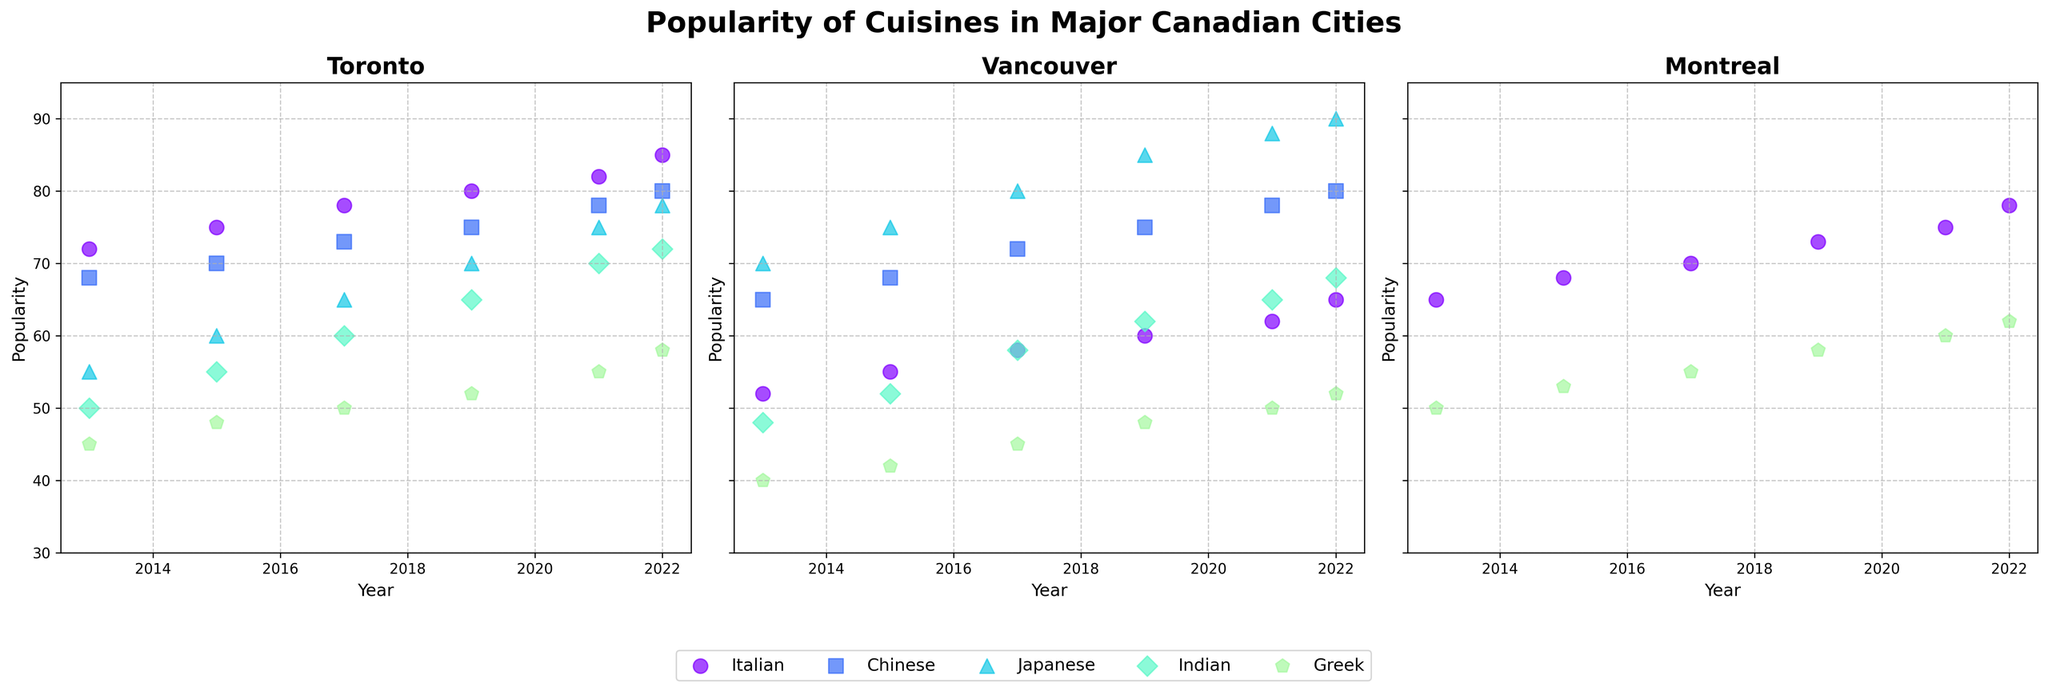Which city has the highest popularity for Japanese cuisine in 2022? Look at Japanese cuisine data points for 2022 in each city's subplot. Vancouver has the highest popularity.
Answer: Vancouver Between 2013 and 2022, which city's Italian cuisine gained the most popularity? Calculate the difference in popularity from 2013 to 2022 for Italian cuisine in each city. Montreal gained 13 (65 to 78), while Toronto gained 13 (72 to 85), and Vancouver gained 13 (52 to 65). All cities gained equally.
Answer: Tie What is the average popularity of Chinese cuisine in Montreal from 2013-2022? The years included are 2013, 2015, 2017, 2019, 2021, and 2022. Sum the popularity values and divide by the number of years: (N/A + N/A + N/A + N/A + N/A + N/A)/6 = N/A
Answer: N/A Which cuisine's popularity in Toronto first reached above 70 in 2015? Look at the 2015 data points in Toronto's subplot and identify the first cuisine surpassing 70. Italian cuisine was the first to reach above 70.
Answer: Italian Compare the trends of Indian cuisine popularity in Vancouver and Montreal between 2013 and 2022. Examine the scatter points for Indian cuisine in both cities, noting the fluctuations over the years. Indian cuisine in Vancouver gradually increased from 48 to 68, while in Montreal it’s not plotted, implying missing data.
Answer: Vancouver increased Between 2019 and 2022, how much did French cuisine popularity increase in Montreal? Find the difference between 2019 and 2022 popularity values for French cuisine in Montreal: 87 - 82 = 5.
Answer: 5 In which year did Toronto see a significant rise in the popularity of Japanese cuisine? Look for a notable increase in the Japanese cuisine scatter points in the Toronto subplot. Between 2019 and 2021, popularity increased significantly from 70 to 75.
Answer: 2021 Is Greek cuisine more popular in Toronto or Vancouver in 2022? Compare the Greek cuisine data points for 2022 in Toronto and Vancouver. Toronto has a higher popularity (58 vs 52).
Answer: Toronto What trend is evident for Lebanese cuisine in Montreal from 2013 to 2022? Review Lebanese cuisine data points from 2013 to 2022 in Montreal's subplot. Note that popularity steadily increases from 2013 to 2022.
Answer: Increasing 